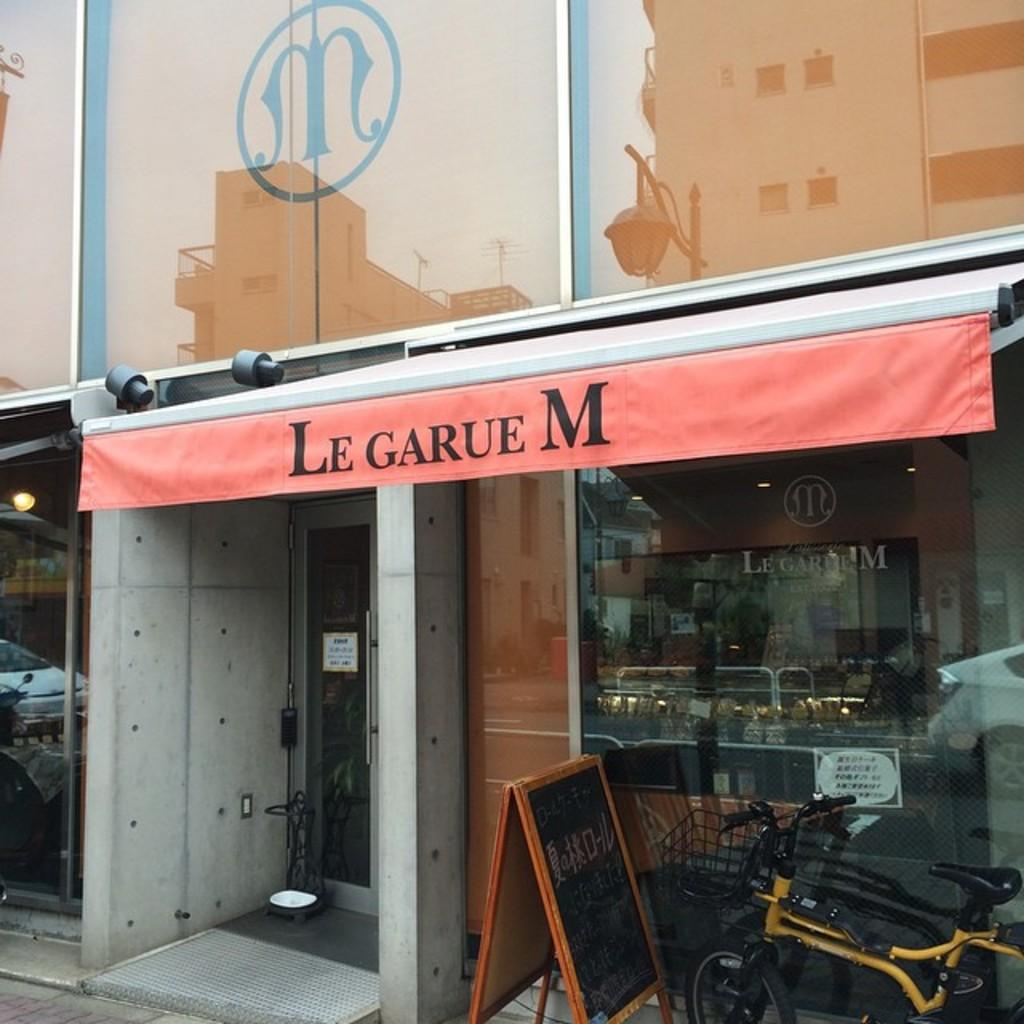What type of structure is visible in the image? There is a building in the image. What type of establishment can be found within the building? There is a store in the image. What is located at the bottom of the image? There is a board and a bicycle at the bottom of the image. What type of pie is being served at the store in the image? There is no pie visible or mentioned in the image. 